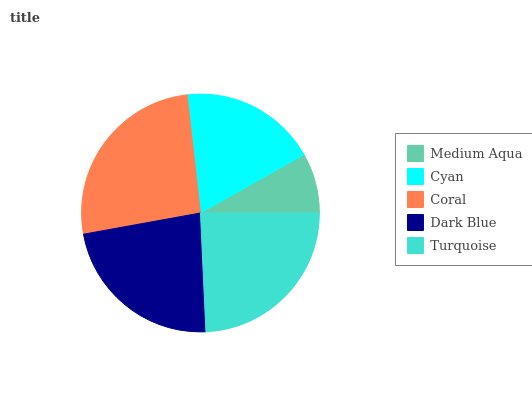Is Medium Aqua the minimum?
Answer yes or no. Yes. Is Coral the maximum?
Answer yes or no. Yes. Is Cyan the minimum?
Answer yes or no. No. Is Cyan the maximum?
Answer yes or no. No. Is Cyan greater than Medium Aqua?
Answer yes or no. Yes. Is Medium Aqua less than Cyan?
Answer yes or no. Yes. Is Medium Aqua greater than Cyan?
Answer yes or no. No. Is Cyan less than Medium Aqua?
Answer yes or no. No. Is Dark Blue the high median?
Answer yes or no. Yes. Is Dark Blue the low median?
Answer yes or no. Yes. Is Cyan the high median?
Answer yes or no. No. Is Turquoise the low median?
Answer yes or no. No. 